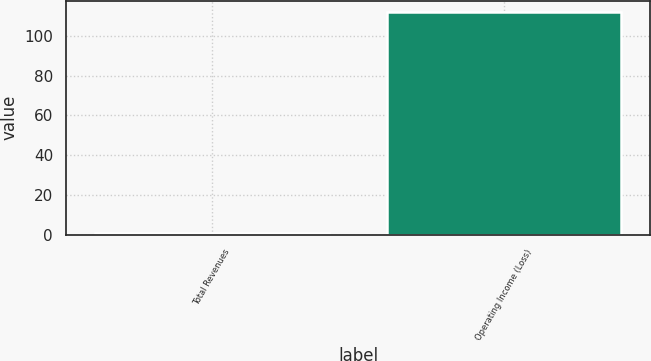Convert chart. <chart><loc_0><loc_0><loc_500><loc_500><bar_chart><fcel>Total Revenues<fcel>Operating Income (Loss)<nl><fcel>1<fcel>112<nl></chart> 